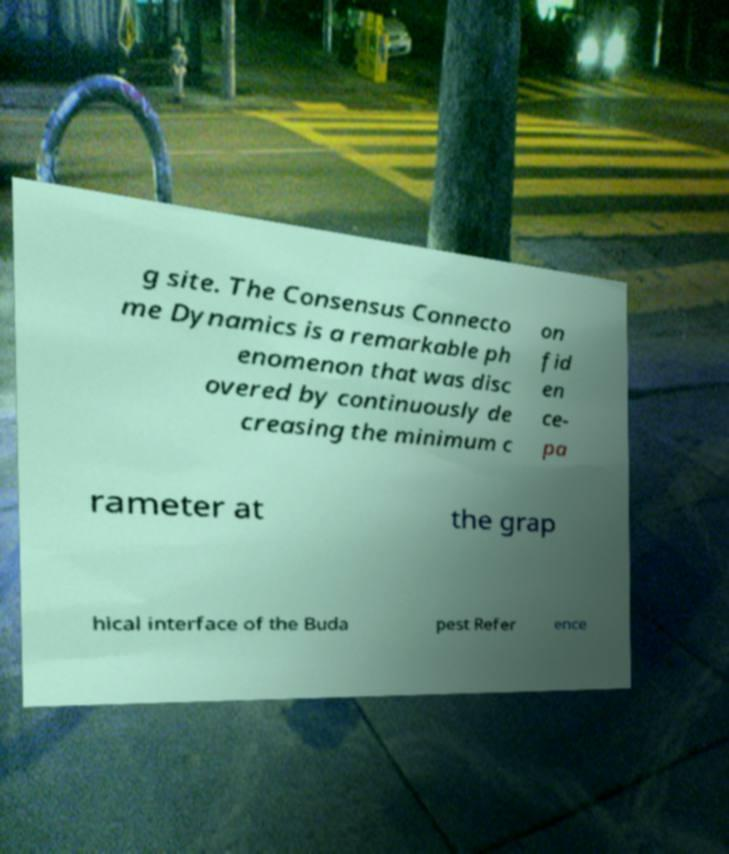Please read and relay the text visible in this image. What does it say? g site. The Consensus Connecto me Dynamics is a remarkable ph enomenon that was disc overed by continuously de creasing the minimum c on fid en ce- pa rameter at the grap hical interface of the Buda pest Refer ence 